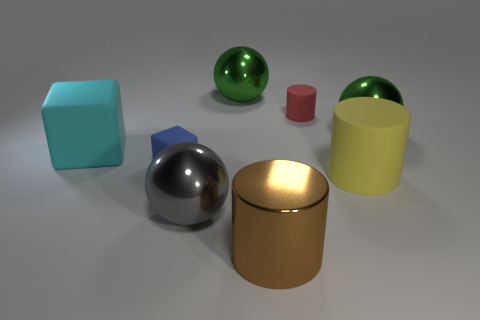Subtract all gray balls. How many balls are left? 2 Subtract all gray balls. How many balls are left? 2 Subtract 3 cylinders. How many cylinders are left? 0 Add 1 matte objects. How many objects exist? 9 Add 8 yellow rubber things. How many yellow rubber things are left? 9 Add 7 big matte cylinders. How many big matte cylinders exist? 8 Subtract 2 green balls. How many objects are left? 6 Subtract all cylinders. How many objects are left? 5 Subtract all blue cubes. Subtract all cyan cylinders. How many cubes are left? 1 Subtract all yellow cylinders. How many purple balls are left? 0 